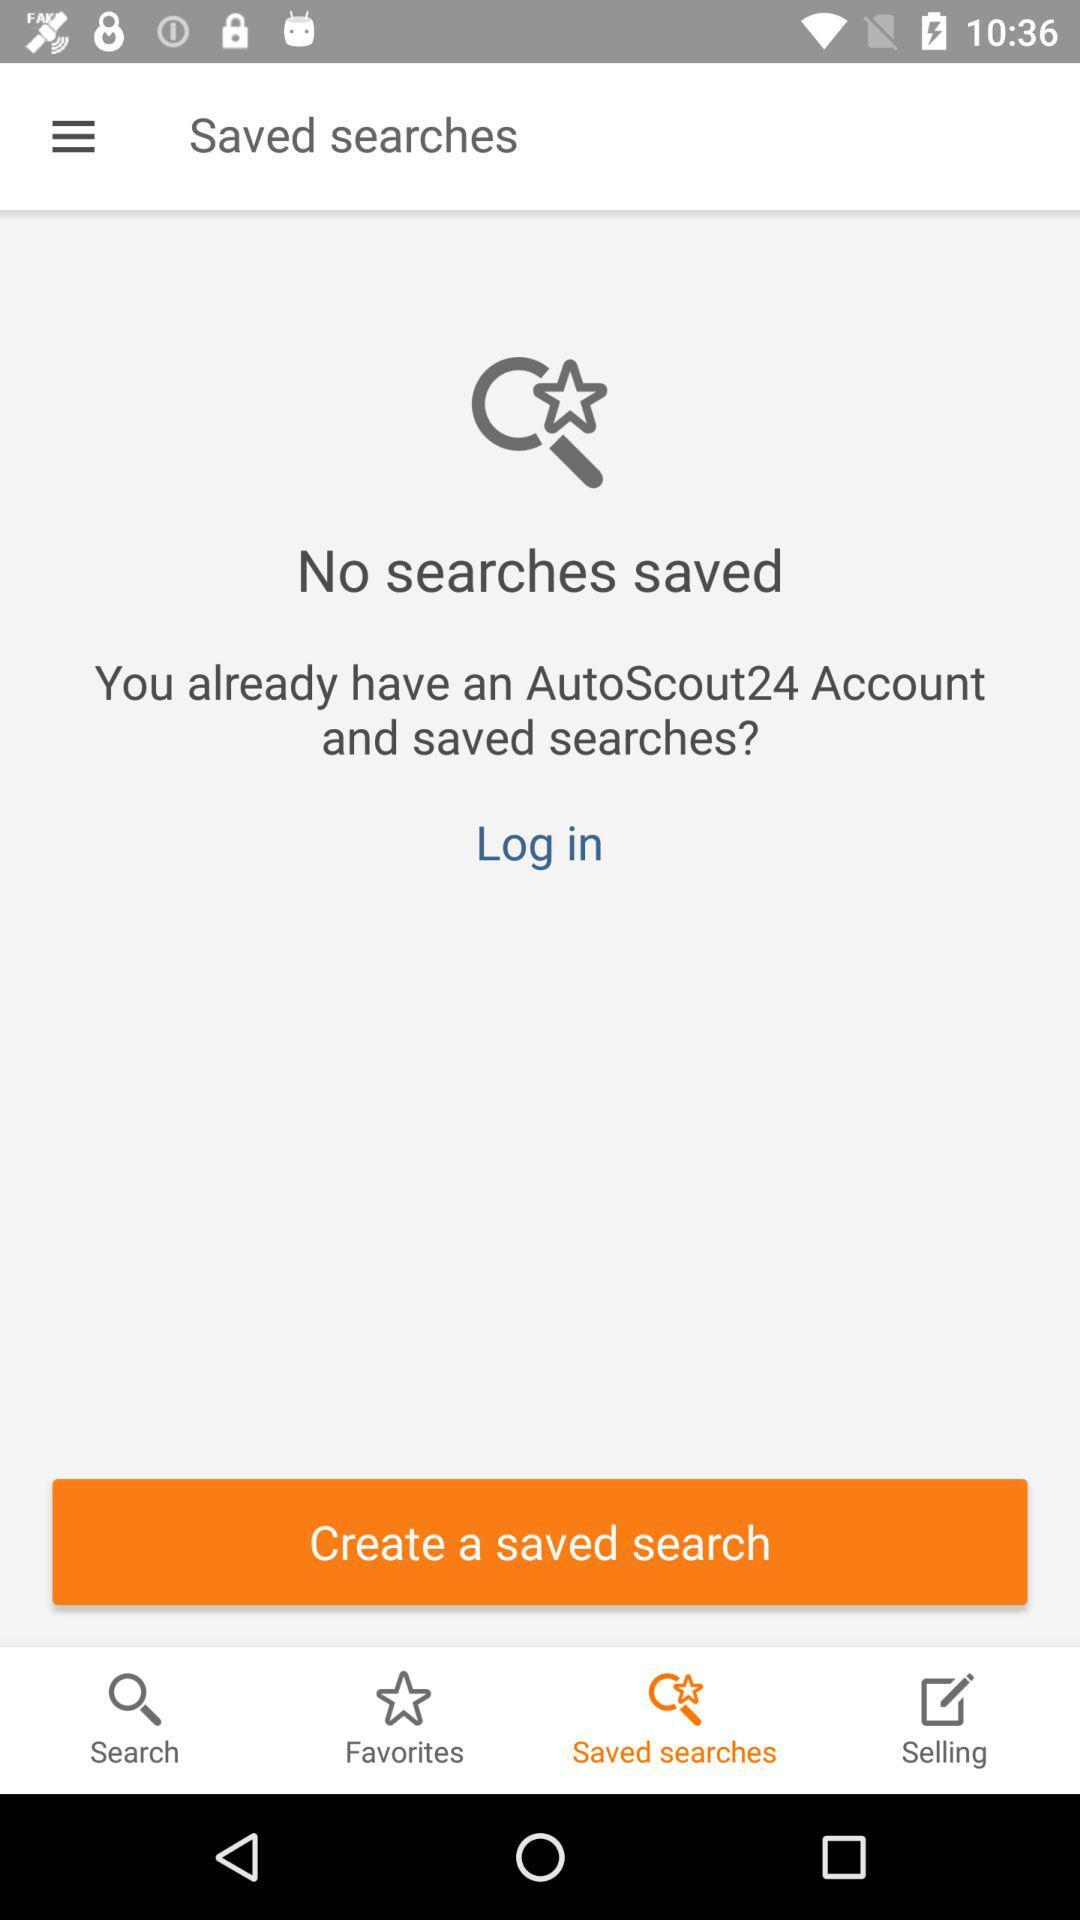How many items are in the "Favorites" tab?
When the provided information is insufficient, respond with <no answer>. <no answer> 